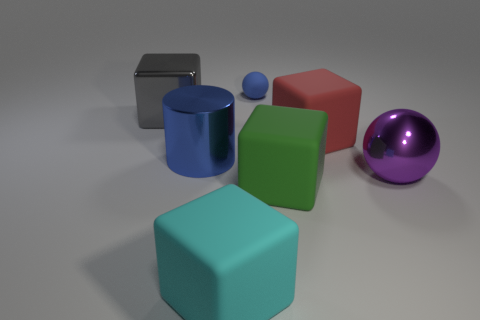There is a blue thing behind the matte block that is behind the shiny thing on the right side of the green block; what is it made of?
Ensure brevity in your answer.  Rubber. Is there any other thing that has the same material as the red thing?
Your answer should be very brief. Yes. There is a shiny block; is it the same size as the thing that is to the right of the big red thing?
Provide a short and direct response. Yes. What number of things are blue things right of the big metallic cylinder or large cubes in front of the large gray metal object?
Give a very brief answer. 4. There is a large matte thing to the left of the small matte sphere; what color is it?
Keep it short and to the point. Cyan. There is a big cube that is on the left side of the large cyan cube; is there a large matte cube that is behind it?
Offer a very short reply. No. Is the number of cyan cubes less than the number of balls?
Ensure brevity in your answer.  Yes. There is a sphere that is on the left side of the large metal object that is to the right of the cyan block; what is it made of?
Your answer should be very brief. Rubber. Does the cyan block have the same size as the purple sphere?
Offer a very short reply. Yes. What number of objects are purple matte spheres or large objects?
Give a very brief answer. 6. 